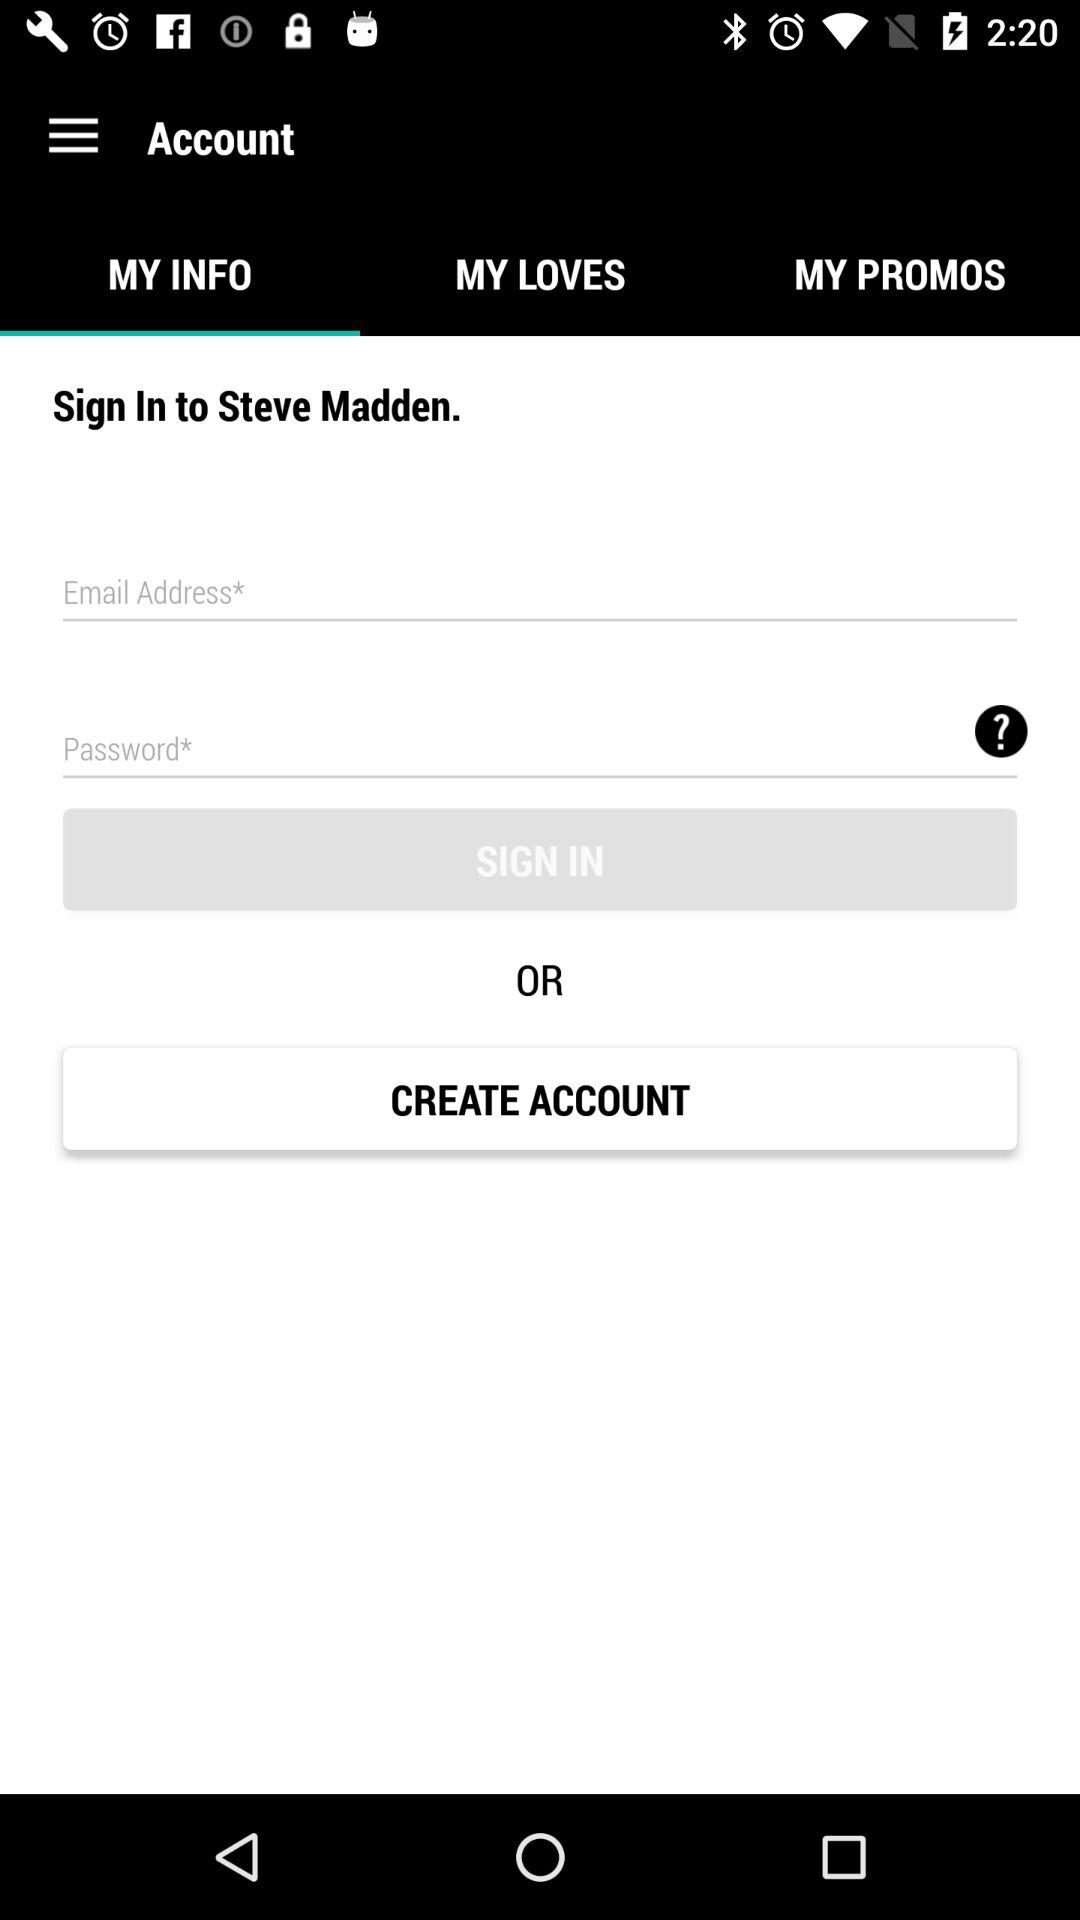Which tab is selected? The selected tab is "MY INFO". 